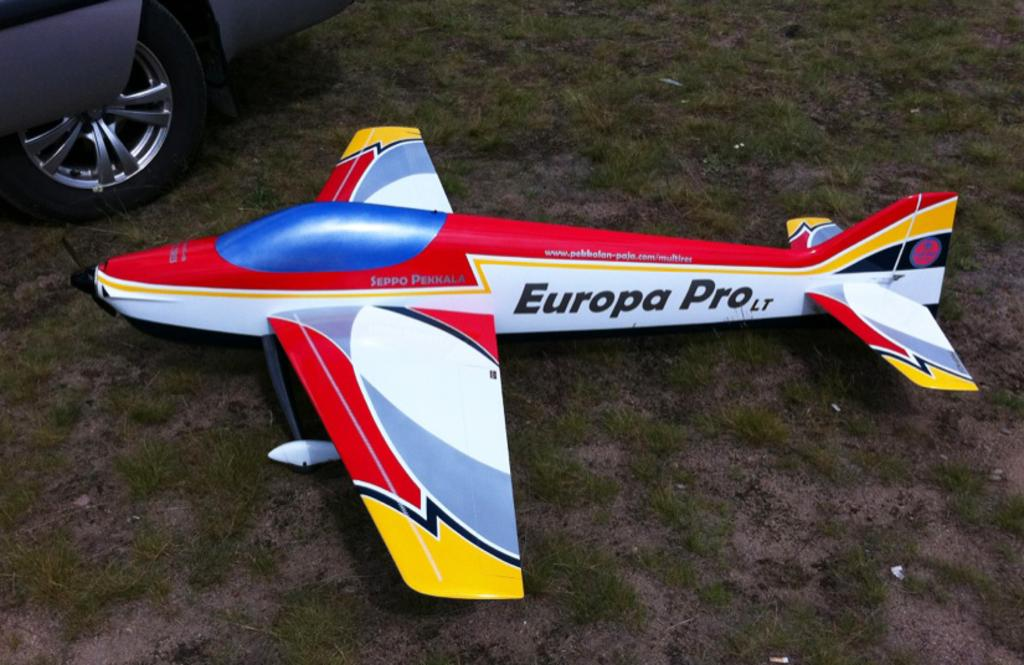<image>
Write a terse but informative summary of the picture. A RC plane with the words Europa Pro on its side. 